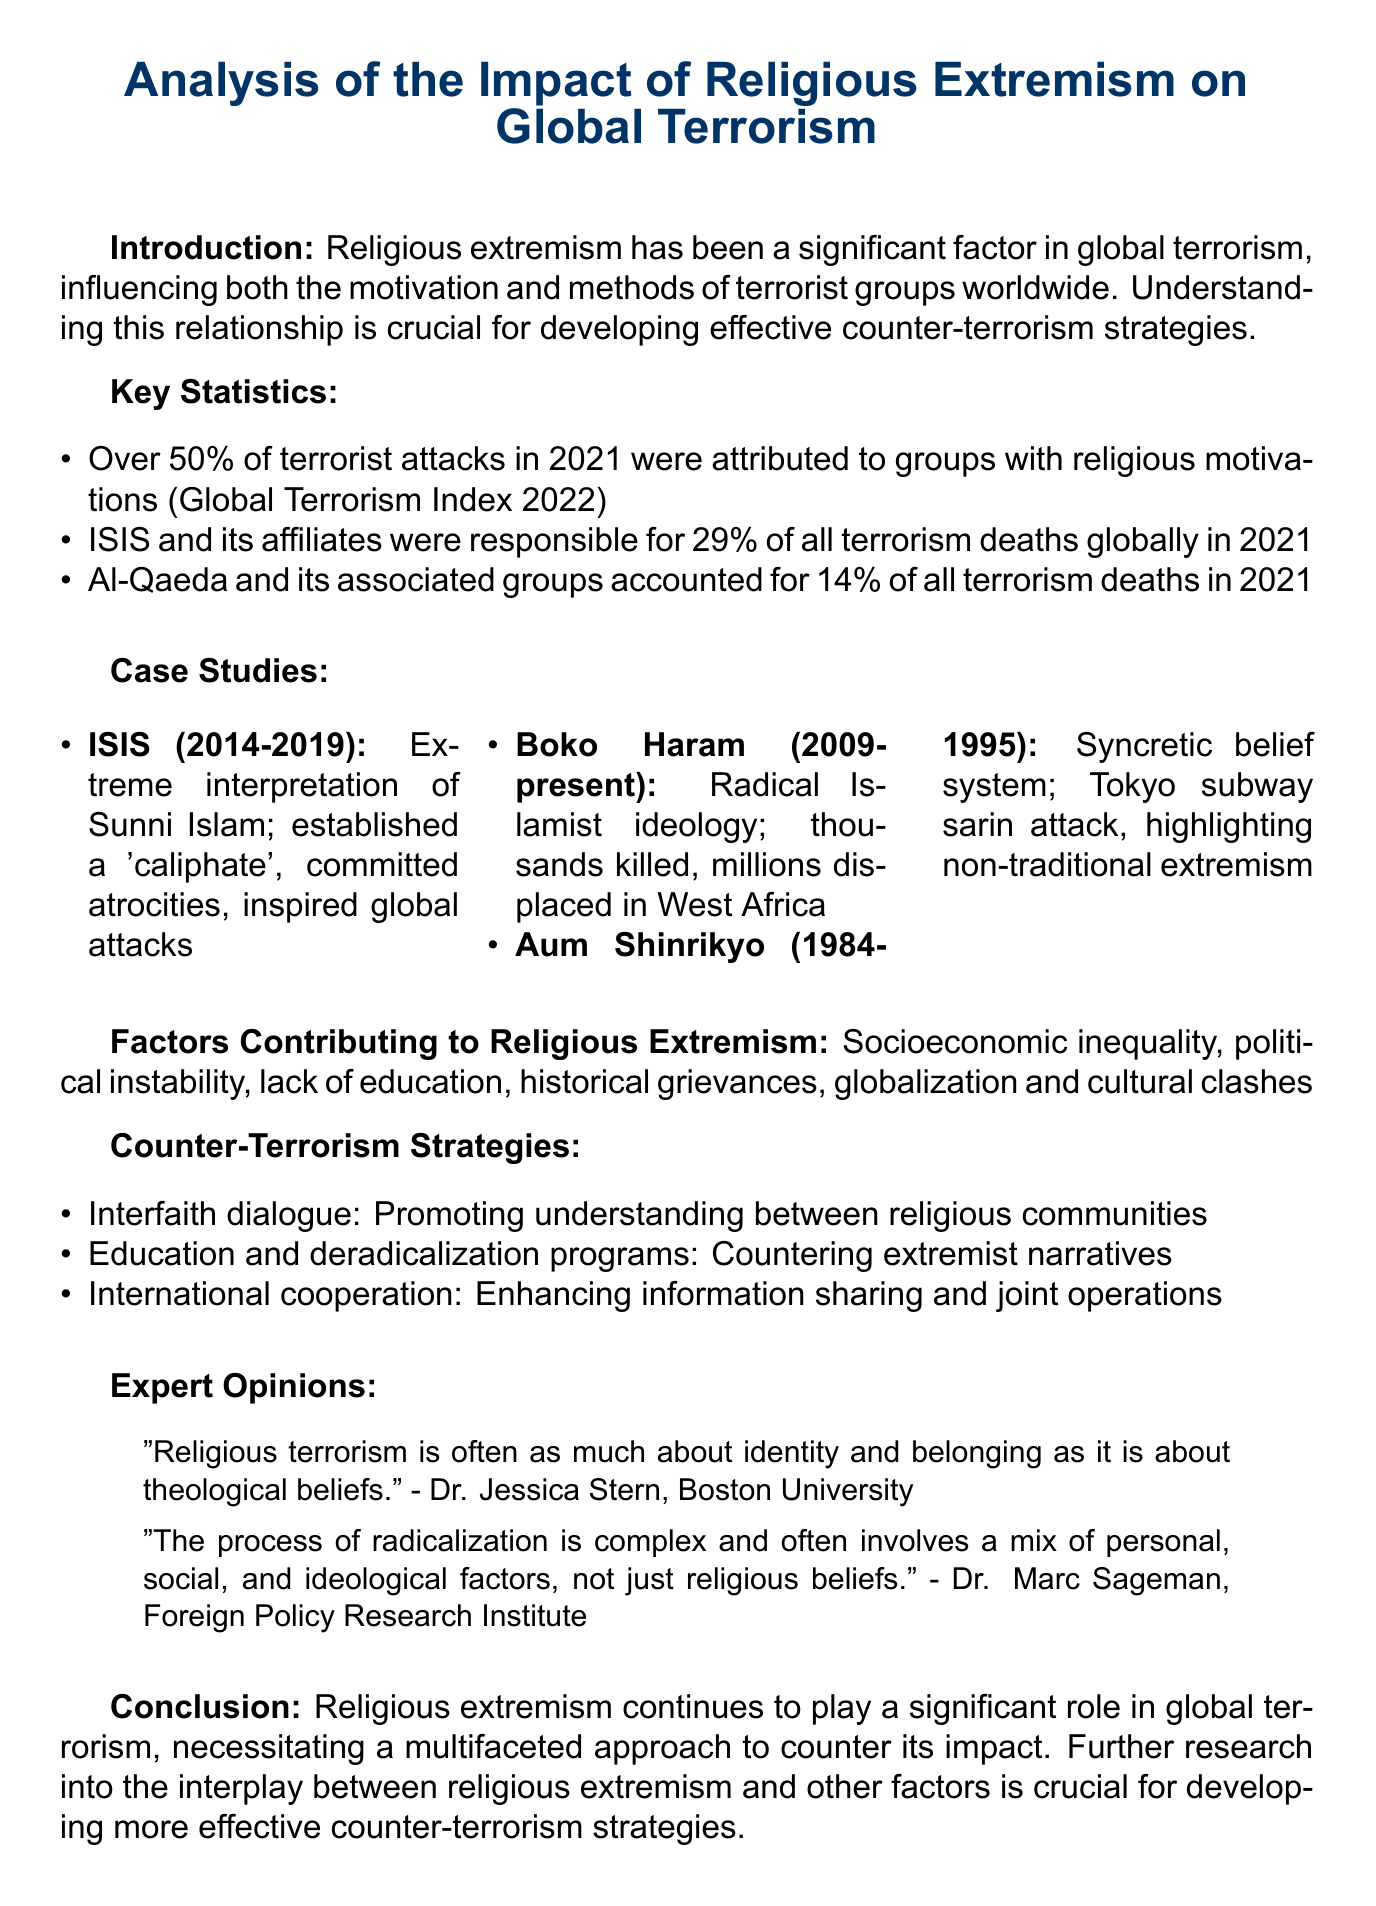What is the title of the memo? The title is explicitly mentioned at the beginning of the document.
Answer: Analysis of the Impact of Religious Extremism on Global Terrorism What percentage of terrorist attacks were attributed to groups with religious motivations in 2021? This statistic is highlighted in the key findings section of the document.
Answer: Over 50% Which group was responsible for 29% of all terrorism deaths globally in 2021? The report lists the key groups tied to terrorism deaths in the statistics section.
Answer: ISIS What is one of the major factors contributing to religious extremism? The document outlines several contributing factors under a specific heading.
Answer: Socioeconomic inequality What is the impact of ISIS in Iraq and Syria during the period of 2014-2019? The document provides a concise summary of the case study regarding ISIS.
Answer: Established a 'caliphate', committed widespread atrocities, and inspired lone-wolf attacks globally According to Dr. Jessica Stern, what is religious terrorism often about? This is based on a quoted expert opinion within the document.
Answer: Identity and belonging What approach does the memo suggest for counter-terrorism? The recommendations for counter-terrorism strategies are listed in a concise manner.
Answer: Interfaith dialogue What is the future research direction mentioned in the conclusion? The conclusion specifies the need for further investigation on a particular topic.
Answer: The interplay between religious extremism and other factors 